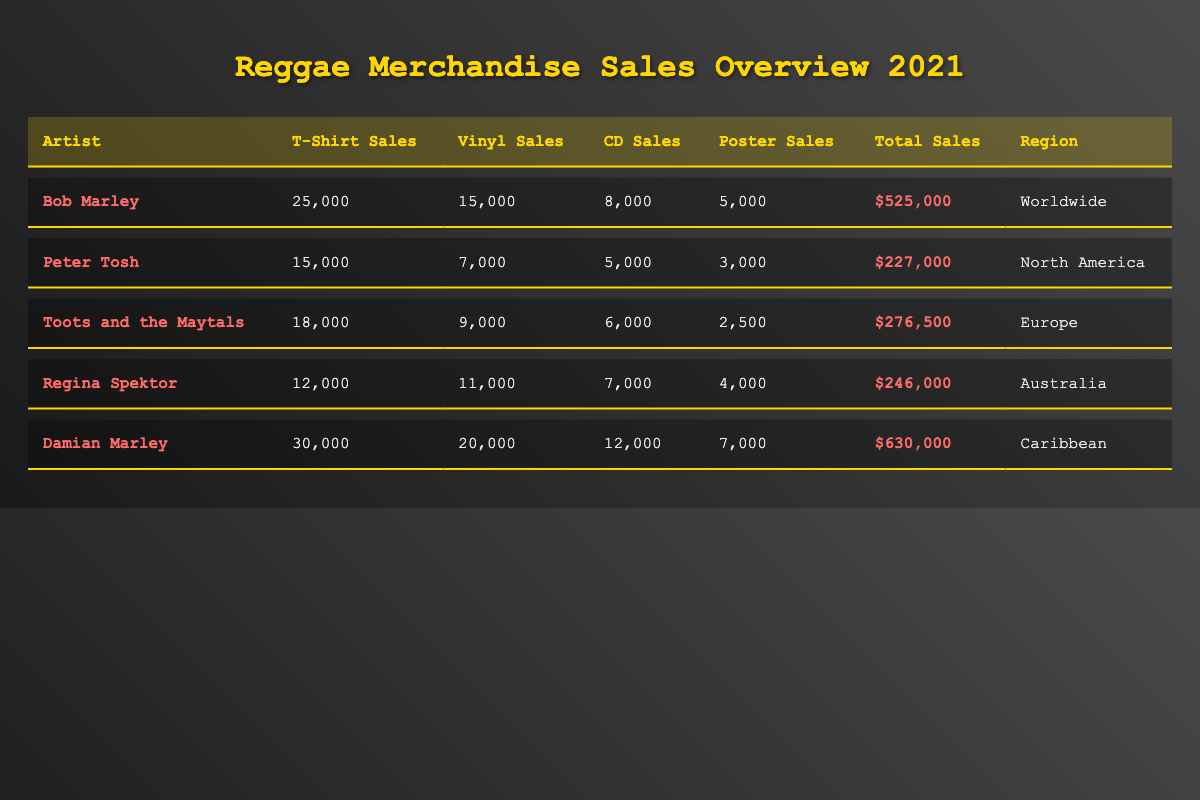What are the total sales for Bob Marley? The total sales for Bob Marley in the table is directly listed under the "Total Sales" column, which shows $525,000.
Answer: $525,000 Which artist had the highest T-shirt sales? By comparing the T-shirt sales for each artist, Damian Marley sold 30,000 T-shirts, which is the highest among all artists listed.
Answer: Damian Marley How many more vinyl sales did Damian Marley have compared to Peter Tosh? Damian Marley had 20,000 vinyl sales while Peter Tosh had 7,000 vinyl sales. The difference is 20,000 - 7,000 = 13,000.
Answer: 13,000 What is the total number of poster sales across all artists? Adding the poster sales for all artists: 5,000 (Bob Marley) + 3,000 (Peter Tosh) + 2,500 (Toots and the Maytals) + 4,000 (Regina Spektor) + 7,000 (Damian Marley) = 21,500.
Answer: 21,500 Is it true that Toots and the Maytals sold more CDs than Regina Spektor? Comparing their CD sales, Toots and the Maytals sold 6,000 CDs while Regina Spektor sold 7,000 CDs. Therefore, the statement is false.
Answer: No What is the average total sales among the artists listed? First, sum the total sales: $525,000 (Bob Marley) + $227,000 (Peter Tosh) + $276,500 (Toots and the Maytals) + $246,000 (Regina Spektor) + $630,000 (Damian Marley) = $1,904,500. Then divide by the number of artists (5), so the average is $1,904,500 / 5 = $380,900.
Answer: $380,900 Who had the lowest total sales, and what was the amount? By reviewing the "Total Sales" column, Peter Tosh has the lowest total sales amounting to $227,000.
Answer: Peter Tosh, $227,000 Calculate the percentage of T-shirt sales out of total sales for Damian Marley. To find the percentage, divide T-shirt sales by total sales: (30,000 / 630,000) * 100 = 4.76%.
Answer: 4.76% Which region had the least total sales among the listed artists? Checking the "Total Sales" in the information, Peter Tosh from North America has the least at $227,000.
Answer: North America What are the total CD sales for all artists combined? Add the CD sales for all artists: 8,000 (Bob Marley) + 5,000 (Peter Tosh) + 6,000 (Toots and the Maytals) + 7,000 (Regina Spektor) + 12,000 (Damian Marley) = 38,000.
Answer: 38,000 